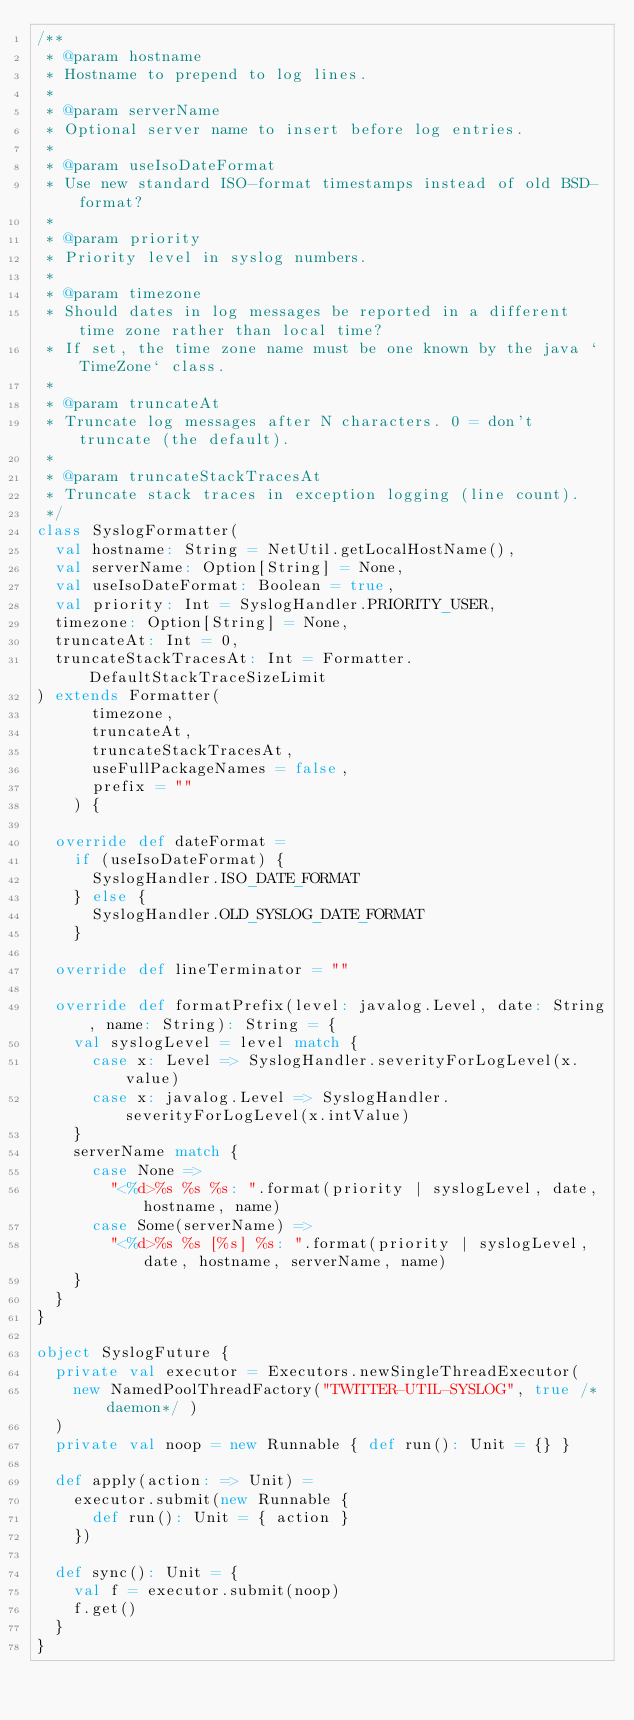Convert code to text. <code><loc_0><loc_0><loc_500><loc_500><_Scala_>/**
 * @param hostname
 * Hostname to prepend to log lines.
 *
 * @param serverName
 * Optional server name to insert before log entries.
 *
 * @param useIsoDateFormat
 * Use new standard ISO-format timestamps instead of old BSD-format?
 *
 * @param priority
 * Priority level in syslog numbers.
 *
 * @param timezone
 * Should dates in log messages be reported in a different time zone rather than local time?
 * If set, the time zone name must be one known by the java `TimeZone` class.
 *
 * @param truncateAt
 * Truncate log messages after N characters. 0 = don't truncate (the default).
 *
 * @param truncateStackTracesAt
 * Truncate stack traces in exception logging (line count).
 */
class SyslogFormatter(
  val hostname: String = NetUtil.getLocalHostName(),
  val serverName: Option[String] = None,
  val useIsoDateFormat: Boolean = true,
  val priority: Int = SyslogHandler.PRIORITY_USER,
  timezone: Option[String] = None,
  truncateAt: Int = 0,
  truncateStackTracesAt: Int = Formatter.DefaultStackTraceSizeLimit
) extends Formatter(
      timezone,
      truncateAt,
      truncateStackTracesAt,
      useFullPackageNames = false,
      prefix = ""
    ) {

  override def dateFormat =
    if (useIsoDateFormat) {
      SyslogHandler.ISO_DATE_FORMAT
    } else {
      SyslogHandler.OLD_SYSLOG_DATE_FORMAT
    }

  override def lineTerminator = ""

  override def formatPrefix(level: javalog.Level, date: String, name: String): String = {
    val syslogLevel = level match {
      case x: Level => SyslogHandler.severityForLogLevel(x.value)
      case x: javalog.Level => SyslogHandler.severityForLogLevel(x.intValue)
    }
    serverName match {
      case None =>
        "<%d>%s %s %s: ".format(priority | syslogLevel, date, hostname, name)
      case Some(serverName) =>
        "<%d>%s %s [%s] %s: ".format(priority | syslogLevel, date, hostname, serverName, name)
    }
  }
}

object SyslogFuture {
  private val executor = Executors.newSingleThreadExecutor(
    new NamedPoolThreadFactory("TWITTER-UTIL-SYSLOG", true /*daemon*/ )
  )
  private val noop = new Runnable { def run(): Unit = {} }

  def apply(action: => Unit) =
    executor.submit(new Runnable {
      def run(): Unit = { action }
    })

  def sync(): Unit = {
    val f = executor.submit(noop)
    f.get()
  }
}
</code> 